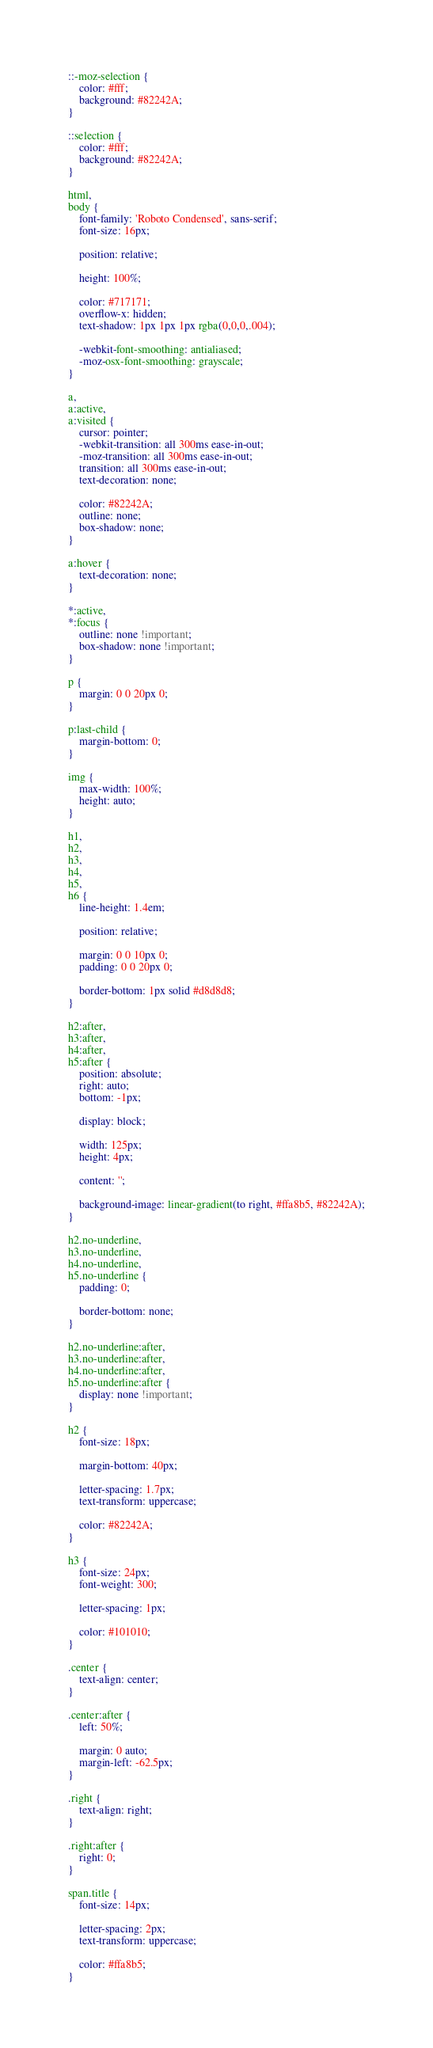<code> <loc_0><loc_0><loc_500><loc_500><_CSS_>

::-moz-selection {
    color: #fff;
    background: #82242A;
}

::selection {
    color: #fff;
    background: #82242A;
}

html,
body {
    font-family: 'Roboto Condensed', sans-serif;
    font-size: 16px;

    position: relative;

    height: 100%;

    color: #717171;
    overflow-x: hidden;
    text-shadow: 1px 1px 1px rgba(0,0,0,.004);

    -webkit-font-smoothing: antialiased;
    -moz-osx-font-smoothing: grayscale;
}

a,
a:active,
a:visited {
    cursor: pointer;
    -webkit-transition: all 300ms ease-in-out;
    -moz-transition: all 300ms ease-in-out;
    transition: all 300ms ease-in-out;
    text-decoration: none;

    color: #82242A;
    outline: none;
    box-shadow: none;
}

a:hover {
    text-decoration: none;
}

*:active,
*:focus {
    outline: none !important;
    box-shadow: none !important;
}

p {
    margin: 0 0 20px 0;
}

p:last-child {
    margin-bottom: 0;
}

img {
    max-width: 100%;
    height: auto;
}

h1,
h2,
h3,
h4,
h5,
h6 {
    line-height: 1.4em;

    position: relative;

    margin: 0 0 10px 0;
    padding: 0 0 20px 0;

    border-bottom: 1px solid #d8d8d8;
}

h2:after,
h3:after,
h4:after,
h5:after {
    position: absolute;
    right: auto;
    bottom: -1px;

    display: block;

    width: 125px;
    height: 4px;

    content: '';

    background-image: linear-gradient(to right, #ffa8b5, #82242A);
}

h2.no-underline,
h3.no-underline,
h4.no-underline,
h5.no-underline {
    padding: 0;

    border-bottom: none;
}

h2.no-underline:after,
h3.no-underline:after,
h4.no-underline:after,
h5.no-underline:after {
    display: none !important;
}

h2 {
    font-size: 18px;

    margin-bottom: 40px;

    letter-spacing: 1.7px;
    text-transform: uppercase;

    color: #82242A;
}

h3 {
    font-size: 24px;
    font-weight: 300;

    letter-spacing: 1px;

    color: #101010;
}

.center {
    text-align: center;
}

.center:after {
    left: 50%;

    margin: 0 auto;
    margin-left: -62.5px;
}

.right {
    text-align: right;
}

.right:after {
    right: 0;
}

span.title {
    font-size: 14px;

    letter-spacing: 2px;
    text-transform: uppercase;

    color: #ffa8b5;
}
</code> 